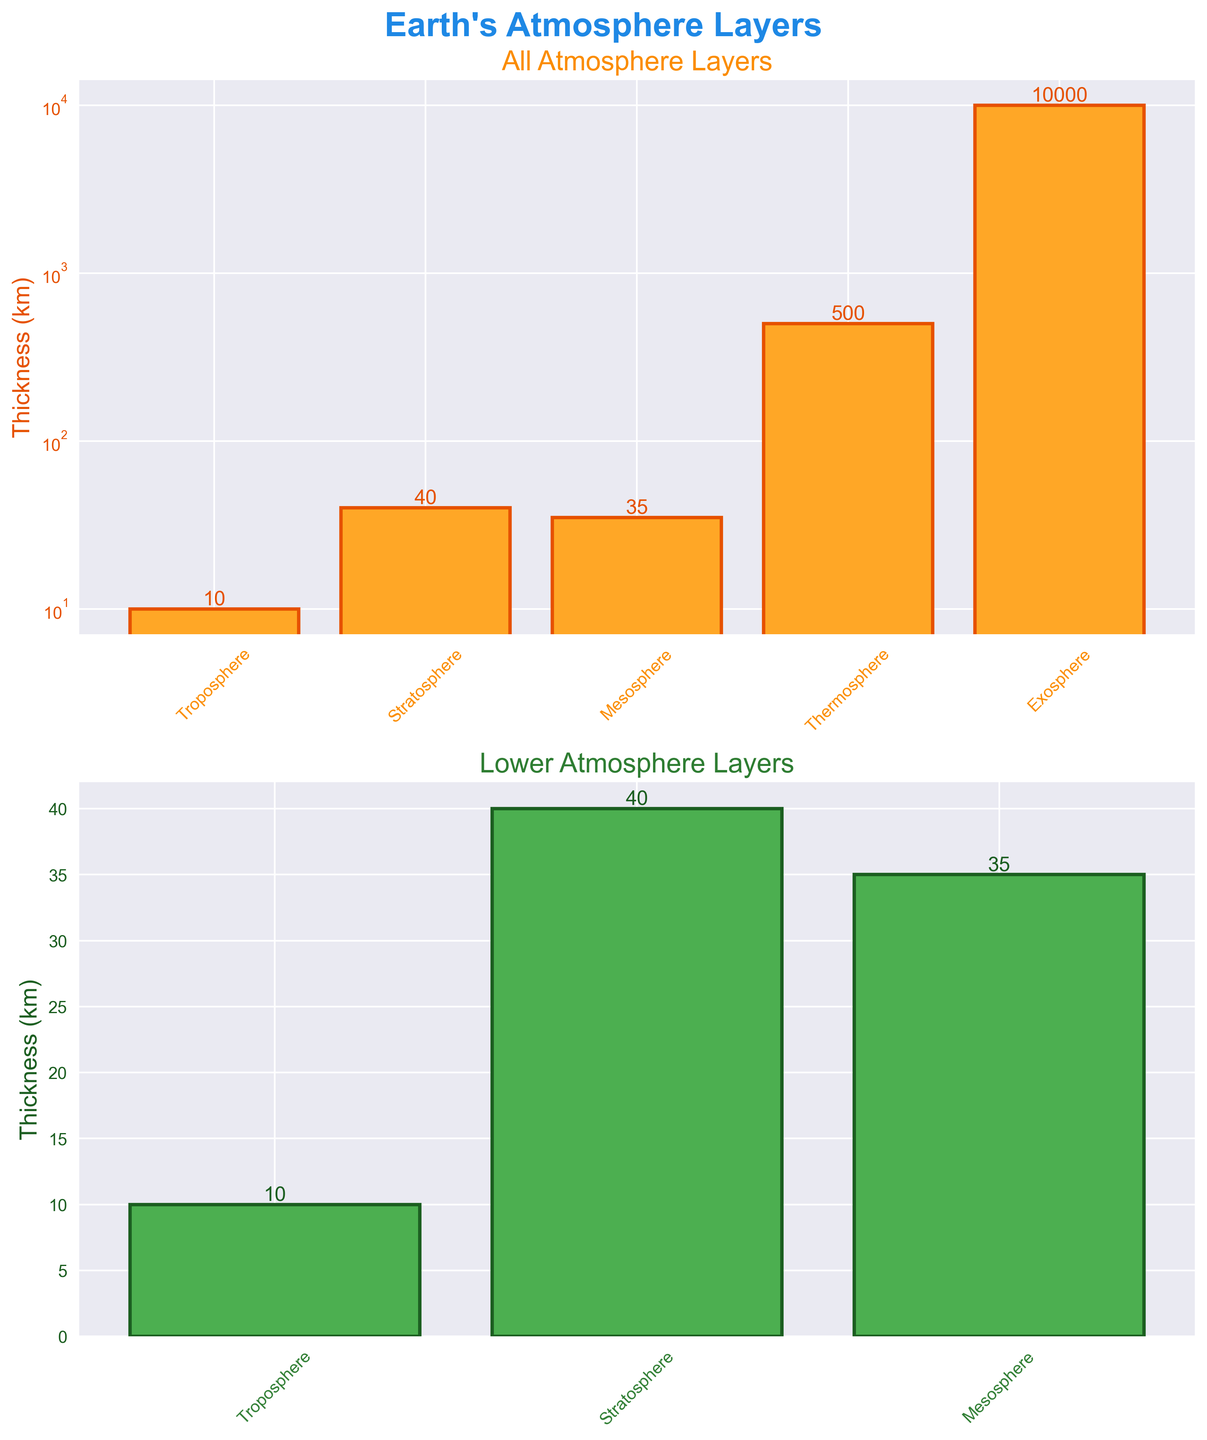Which layer is the thickest? The figure shows the Exosphere has the highest bar among all layers, indicating it is the thickest.
Answer: Exosphere What is the thickness of the Mesosphere? The bar labeled Mesosphere reaches up to 35 km on the y-axis.
Answer: 35 km How many layers are shown in the lower atmosphere subplot? The lower atmosphere subplot displays 3 bars, corresponding to the lower layers Troposphere, Stratosphere, and Mesosphere.
Answer: 3 Which layer is thicker, the Stratosphere or the Mesosphere? Comparing the heights of the bars, the Stratosphere (40 km) is slightly taller than the Mesosphere (35 km).
Answer: Stratosphere What is the title of the top subplot? The title above the top subplot reads "All Atmosphere Layers."
Answer: All Atmosphere Layers What's the difference in thickness between the Thermosphere and Troposphere? The Thermosphere bar reaches 500 km and the Troposphere bar reaches 10 km. The difference is 500 - 10 = 490 km.
Answer: 490 km Which layer has the lowest thickness, and what is its value? The shortest bar corresponds to the Troposphere, which has a thickness of 10 km.
Answer: Troposphere, 10 km Based on the figure, does the lower atmosphere (Troposphere, Stratosphere, Mesosphere) all together compared in thickness to the Exosphere? Summing the thicknesses of Troposphere (10 km), Stratosphere (40 km), and Mesosphere (35 km), we get 10 + 40 + 35 = 85 km, which is much less than the Exosphere's 10000 km.
Answer: Less What color represents the bars of the lower atmosphere layers? The bars in the lower subplot are painted in green.
Answer: Green How is the y-axis scale represented in the top subplot? The y-axis of the top subplot uses a logarithmic scale, indicated by the unequal spacing of numbers.
Answer: Logarithmic 